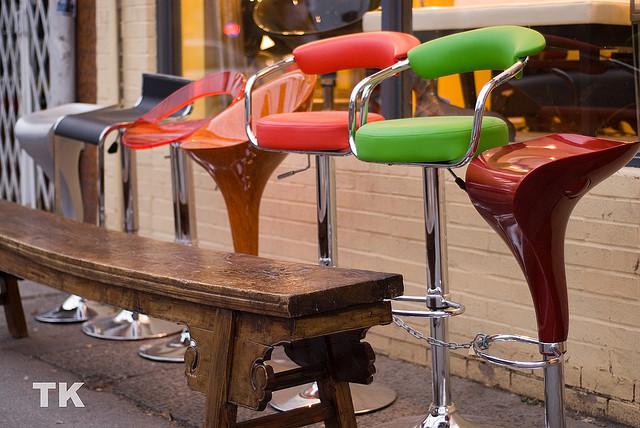How many stools are there?
Answer briefly. 8. Where is the wooden bench?
Quick response, please. In front of chairs. Is this a furniture store?
Short answer required. Yes. 